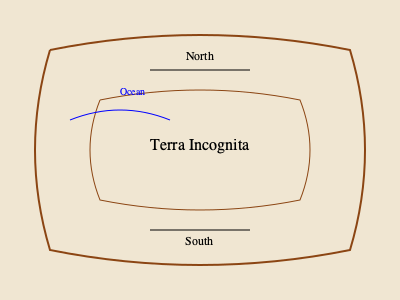Based on the cartographic style and features shown in this map fragment, estimate its approximate age. Which century was this map most likely created in? To estimate the age of this map, we need to analyze several key features:

1. Cartouche style: The map uses decorative borders and text styling typical of 16th-17th century maps.

2. "Terra Incognita": This Latin phrase, meaning "unknown land," was commonly used in maps from the Age of Exploration (15th-17th centuries) to denote unexplored areas.

3. Limited geographical detail: The map shows minimal inland features, suggesting limited exploration, which was common in early modern cartography.

4. Stylized coastlines: The curved, artistic representation of coastlines was prevalent in maps from the 16th-17th centuries.

5. Compass directions: The simple "North" and "South" labels without a compass rose suggest an earlier period in cartographic development.

6. Ocean representation: The stylized waves for the ocean are characteristic of maps from the 16th-17th centuries.

Given these features, particularly the use of "Terra Incognita" and the artistic style, this map most likely dates to the 16th century, during the early stages of European global exploration and mapping.
Answer: 16th century 